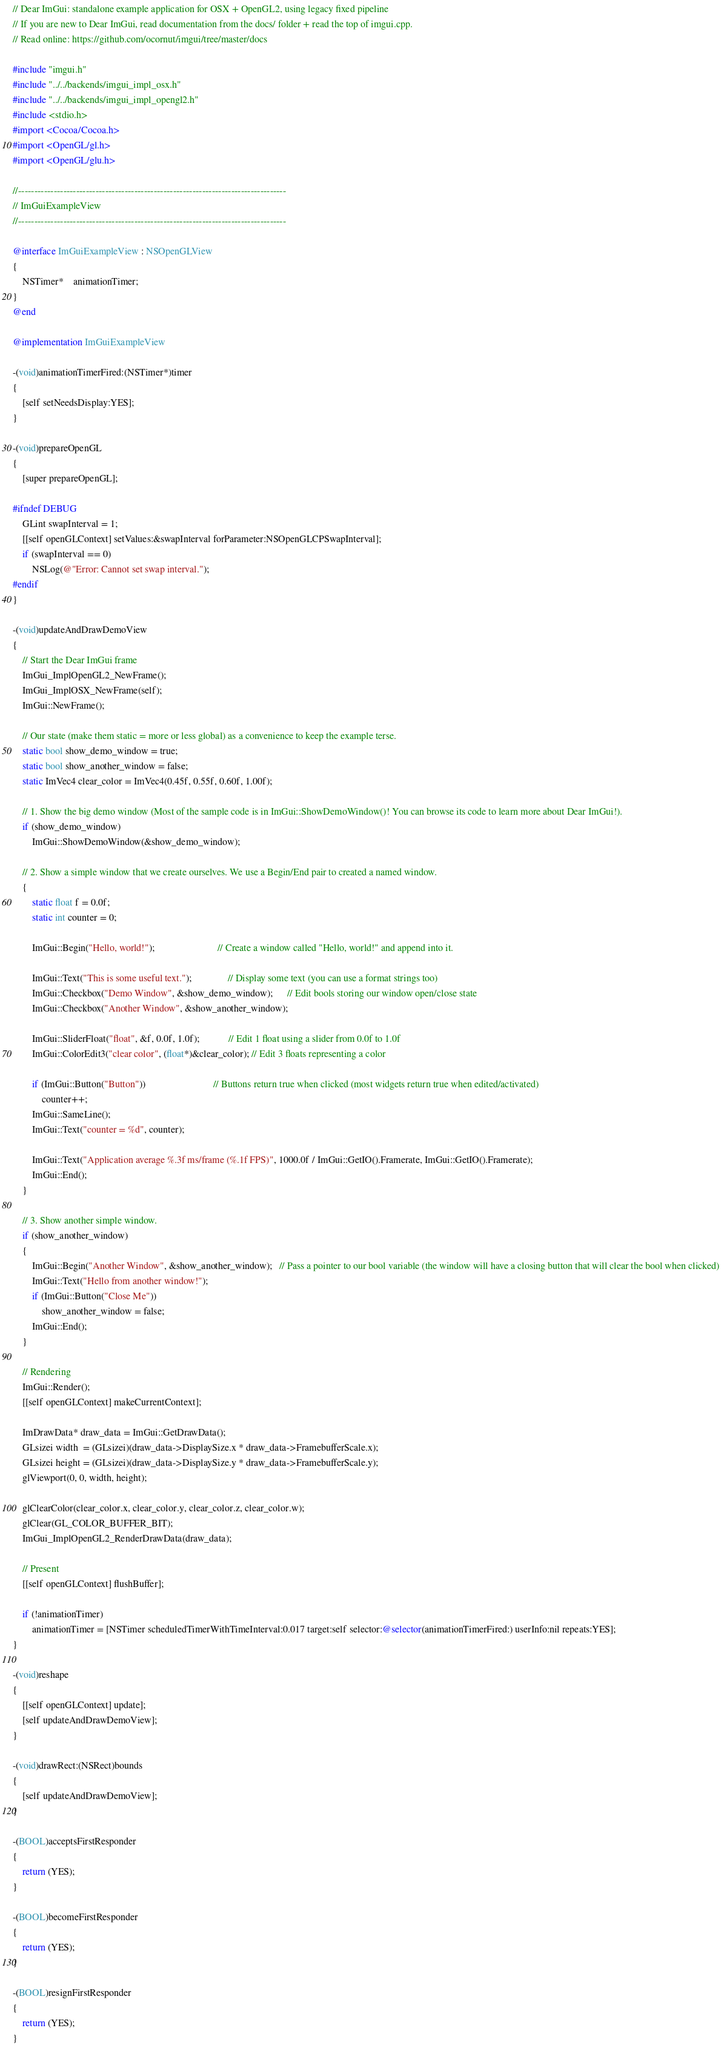Convert code to text. <code><loc_0><loc_0><loc_500><loc_500><_ObjectiveC_>// Dear ImGui: standalone example application for OSX + OpenGL2, using legacy fixed pipeline
// If you are new to Dear ImGui, read documentation from the docs/ folder + read the top of imgui.cpp.
// Read online: https://github.com/ocornut/imgui/tree/master/docs

#include "imgui.h"
#include "../../backends/imgui_impl_osx.h"
#include "../../backends/imgui_impl_opengl2.h"
#include <stdio.h>
#import <Cocoa/Cocoa.h>
#import <OpenGL/gl.h>
#import <OpenGL/glu.h>

//-----------------------------------------------------------------------------------
// ImGuiExampleView
//-----------------------------------------------------------------------------------

@interface ImGuiExampleView : NSOpenGLView
{
    NSTimer*    animationTimer;
}
@end

@implementation ImGuiExampleView

-(void)animationTimerFired:(NSTimer*)timer
{
    [self setNeedsDisplay:YES];
}

-(void)prepareOpenGL
{
    [super prepareOpenGL];

#ifndef DEBUG
    GLint swapInterval = 1;
    [[self openGLContext] setValues:&swapInterval forParameter:NSOpenGLCPSwapInterval];
    if (swapInterval == 0)
        NSLog(@"Error: Cannot set swap interval.");
#endif
}

-(void)updateAndDrawDemoView
{
    // Start the Dear ImGui frame
	ImGui_ImplOpenGL2_NewFrame();
	ImGui_ImplOSX_NewFrame(self);
    ImGui::NewFrame();

    // Our state (make them static = more or less global) as a convenience to keep the example terse.
    static bool show_demo_window = true;
    static bool show_another_window = false;
    static ImVec4 clear_color = ImVec4(0.45f, 0.55f, 0.60f, 1.00f);

    // 1. Show the big demo window (Most of the sample code is in ImGui::ShowDemoWindow()! You can browse its code to learn more about Dear ImGui!).
    if (show_demo_window)
        ImGui::ShowDemoWindow(&show_demo_window);

    // 2. Show a simple window that we create ourselves. We use a Begin/End pair to created a named window.
    {
        static float f = 0.0f;
        static int counter = 0;

        ImGui::Begin("Hello, world!");                          // Create a window called "Hello, world!" and append into it.

        ImGui::Text("This is some useful text.");               // Display some text (you can use a format strings too)
        ImGui::Checkbox("Demo Window", &show_demo_window);      // Edit bools storing our window open/close state
        ImGui::Checkbox("Another Window", &show_another_window);

        ImGui::SliderFloat("float", &f, 0.0f, 1.0f);            // Edit 1 float using a slider from 0.0f to 1.0f
        ImGui::ColorEdit3("clear color", (float*)&clear_color); // Edit 3 floats representing a color

        if (ImGui::Button("Button"))                            // Buttons return true when clicked (most widgets return true when edited/activated)
            counter++;
        ImGui::SameLine();
        ImGui::Text("counter = %d", counter);

        ImGui::Text("Application average %.3f ms/frame (%.1f FPS)", 1000.0f / ImGui::GetIO().Framerate, ImGui::GetIO().Framerate);
        ImGui::End();
    }

    // 3. Show another simple window.
    if (show_another_window)
    {
        ImGui::Begin("Another Window", &show_another_window);   // Pass a pointer to our bool variable (the window will have a closing button that will clear the bool when clicked)
        ImGui::Text("Hello from another window!");
        if (ImGui::Button("Close Me"))
            show_another_window = false;
        ImGui::End();
    }

	// Rendering
	ImGui::Render();
	[[self openGLContext] makeCurrentContext];

    ImDrawData* draw_data = ImGui::GetDrawData();
    GLsizei width  = (GLsizei)(draw_data->DisplaySize.x * draw_data->FramebufferScale.x);
    GLsizei height = (GLsizei)(draw_data->DisplaySize.y * draw_data->FramebufferScale.y);
    glViewport(0, 0, width, height);

	glClearColor(clear_color.x, clear_color.y, clear_color.z, clear_color.w);
	glClear(GL_COLOR_BUFFER_BIT);
	ImGui_ImplOpenGL2_RenderDrawData(draw_data);

    // Present
    [[self openGLContext] flushBuffer];

    if (!animationTimer)
        animationTimer = [NSTimer scheduledTimerWithTimeInterval:0.017 target:self selector:@selector(animationTimerFired:) userInfo:nil repeats:YES];
}

-(void)reshape
{
    [[self openGLContext] update];
    [self updateAndDrawDemoView];
}

-(void)drawRect:(NSRect)bounds
{
    [self updateAndDrawDemoView];
}

-(BOOL)acceptsFirstResponder
{
    return (YES);
}

-(BOOL)becomeFirstResponder
{
    return (YES);
}

-(BOOL)resignFirstResponder
{
    return (YES);
}
</code> 